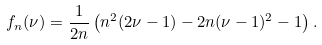<formula> <loc_0><loc_0><loc_500><loc_500>f _ { n } ( \nu ) = \frac { 1 } { 2 n } \left ( n ^ { 2 } ( 2 \nu - 1 ) - 2 n ( \nu - 1 ) ^ { 2 } - 1 \right ) .</formula> 